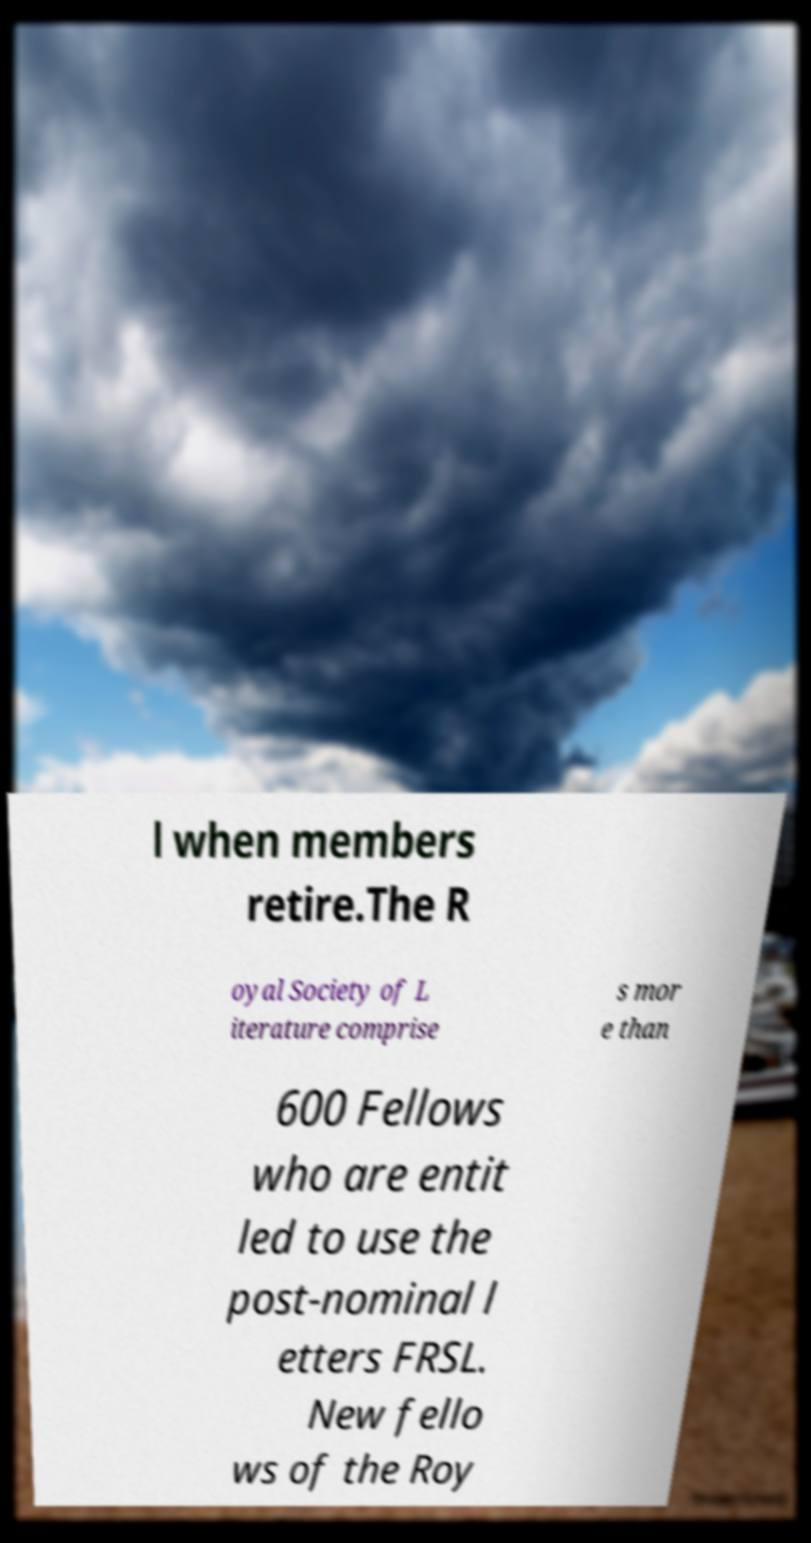Please identify and transcribe the text found in this image. l when members retire.The R oyal Society of L iterature comprise s mor e than 600 Fellows who are entit led to use the post-nominal l etters FRSL. New fello ws of the Roy 